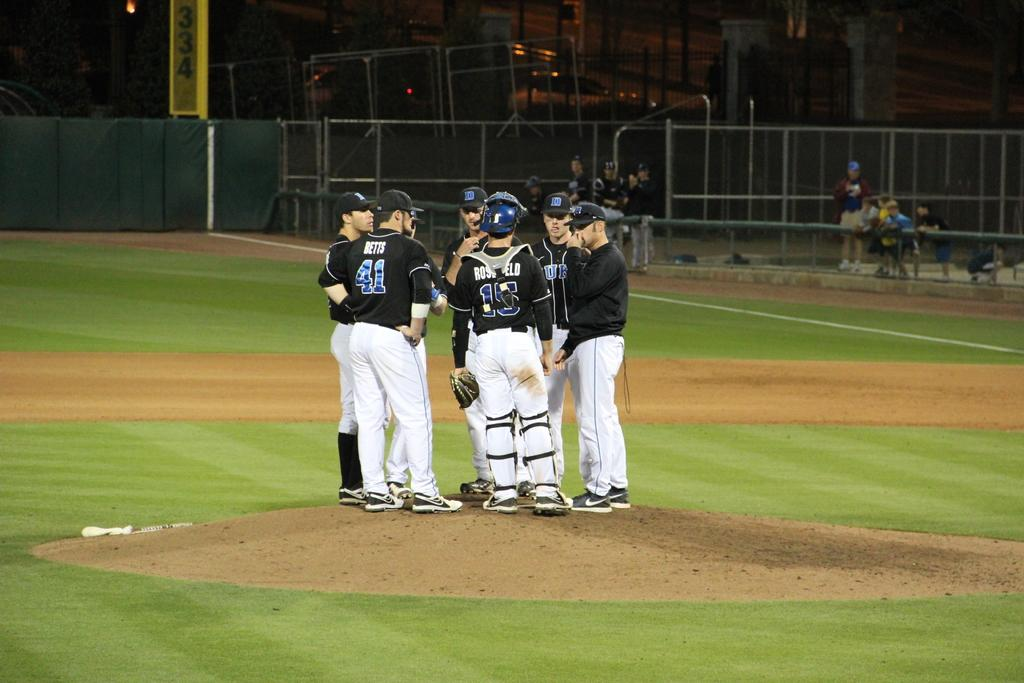<image>
Summarize the visual content of the image. a group of players gathered at the mound with one wearing 41 